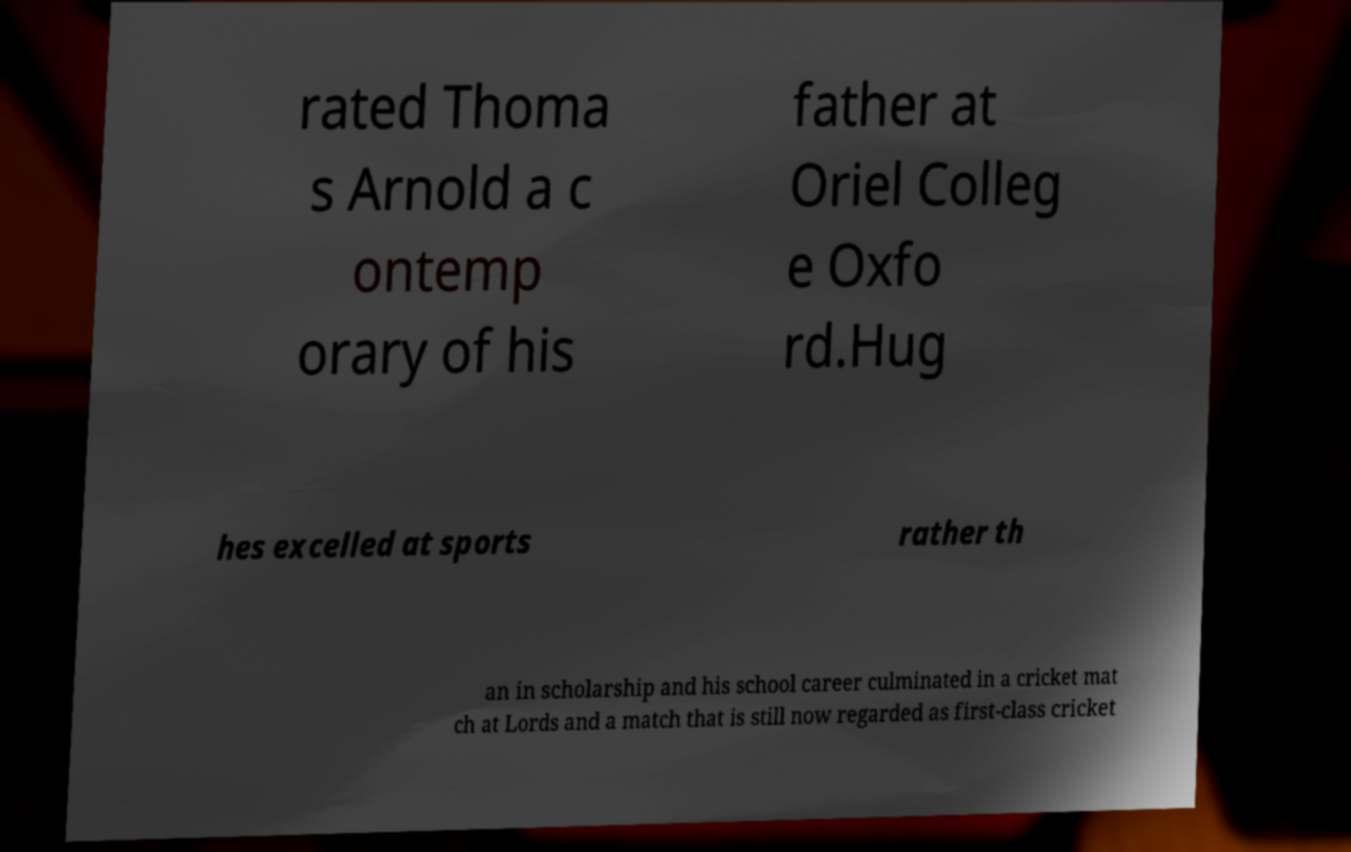Could you extract and type out the text from this image? rated Thoma s Arnold a c ontemp orary of his father at Oriel Colleg e Oxfo rd.Hug hes excelled at sports rather th an in scholarship and his school career culminated in a cricket mat ch at Lords and a match that is still now regarded as first-class cricket 